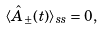<formula> <loc_0><loc_0><loc_500><loc_500>\langle \hat { A } _ { \pm } ( t ) \rangle _ { s s } = 0 ,</formula> 